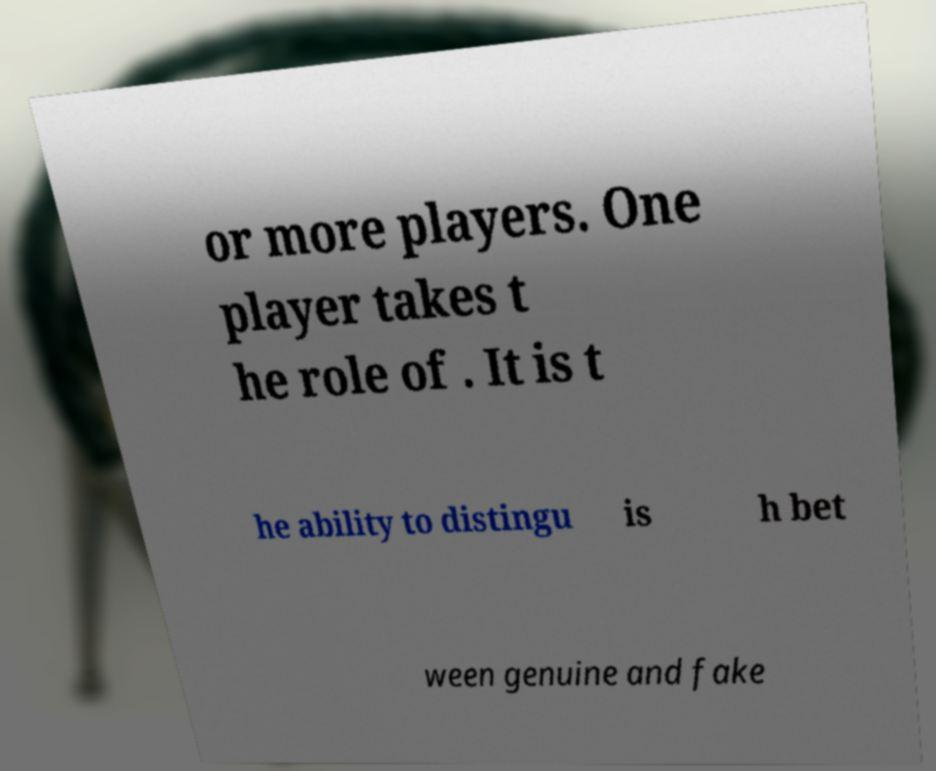What messages or text are displayed in this image? I need them in a readable, typed format. or more players. One player takes t he role of . It is t he ability to distingu is h bet ween genuine and fake 